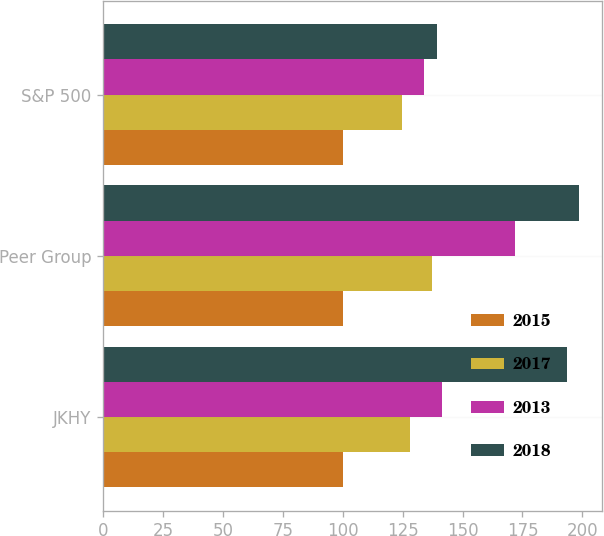Convert chart to OTSL. <chart><loc_0><loc_0><loc_500><loc_500><stacked_bar_chart><ecel><fcel>JKHY<fcel>Peer Group<fcel>S&P 500<nl><fcel>2015<fcel>100<fcel>100<fcel>100<nl><fcel>2017<fcel>128.02<fcel>137.07<fcel>124.61<nl><fcel>2013<fcel>141.48<fcel>171.8<fcel>133.86<nl><fcel>2018<fcel>193.46<fcel>198.44<fcel>139.2<nl></chart> 